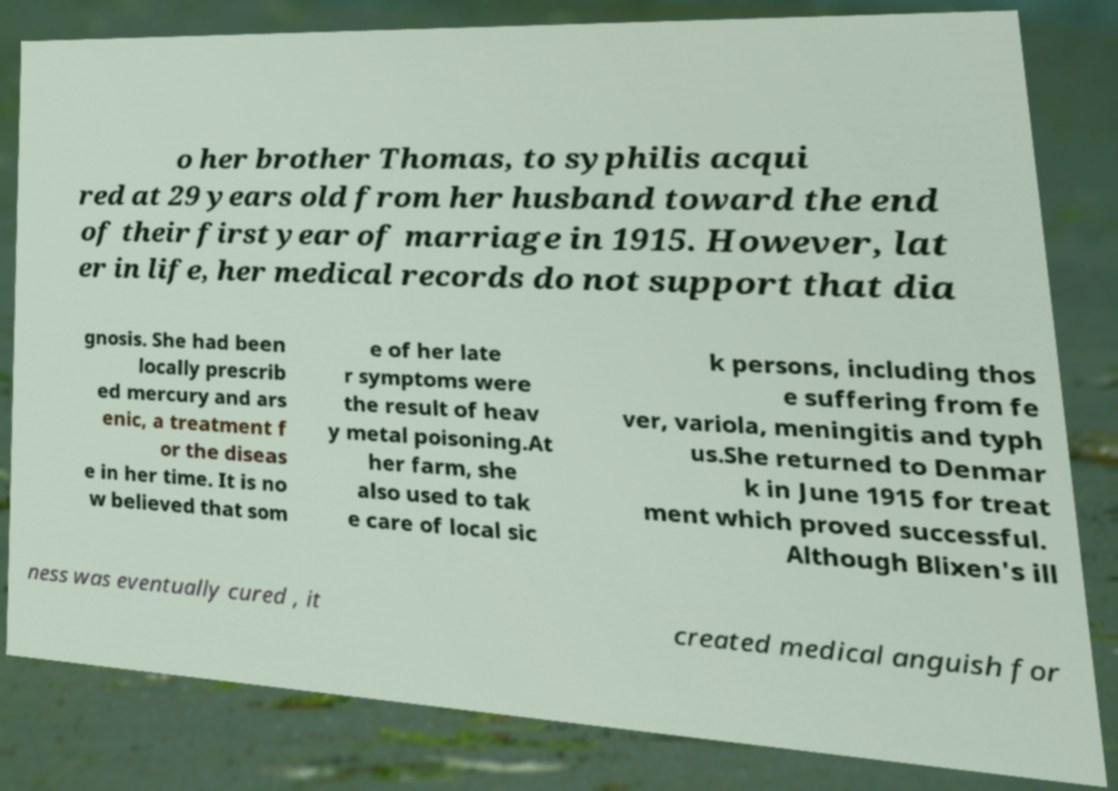Can you read and provide the text displayed in the image?This photo seems to have some interesting text. Can you extract and type it out for me? o her brother Thomas, to syphilis acqui red at 29 years old from her husband toward the end of their first year of marriage in 1915. However, lat er in life, her medical records do not support that dia gnosis. She had been locally prescrib ed mercury and ars enic, a treatment f or the diseas e in her time. It is no w believed that som e of her late r symptoms were the result of heav y metal poisoning.At her farm, she also used to tak e care of local sic k persons, including thos e suffering from fe ver, variola, meningitis and typh us.She returned to Denmar k in June 1915 for treat ment which proved successful. Although Blixen's ill ness was eventually cured , it created medical anguish for 